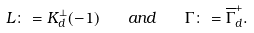<formula> <loc_0><loc_0><loc_500><loc_500>L \colon = K _ { d } ^ { \perp } ( - 1 ) \quad a n d \quad \Gamma \colon = \overline { \Gamma } _ { d } ^ { + } .</formula> 